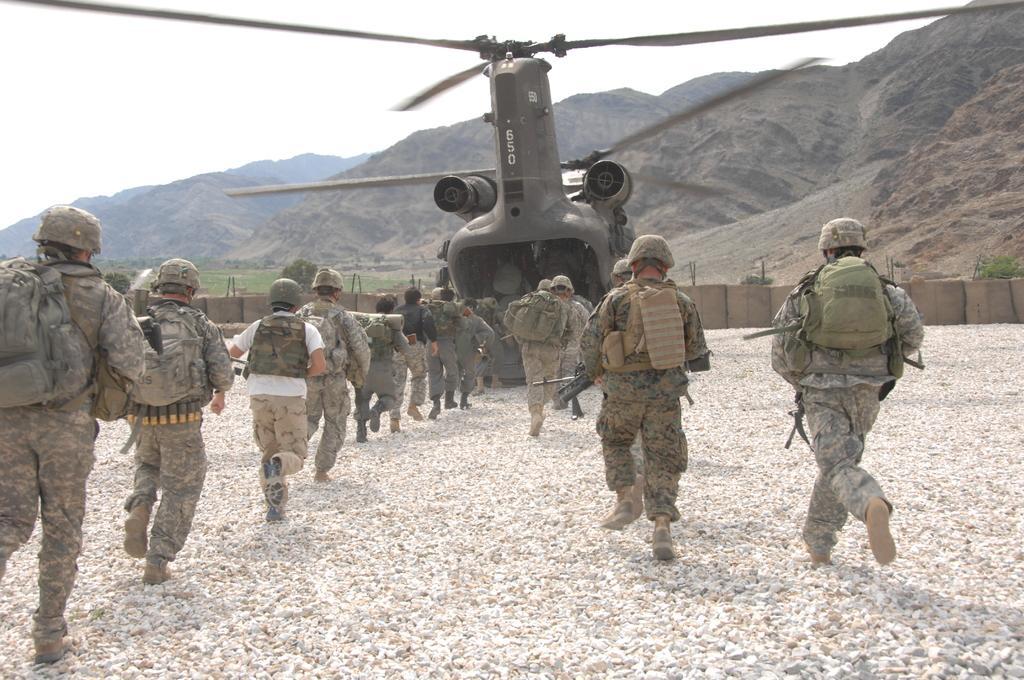How would you summarize this image in a sentence or two? In this image we can see some soldiers carrying backpacks holding weapons in their hands walking in to the helicopter and at the background of the image there are some mountains and clear sky. 